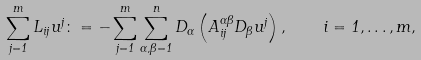Convert formula to latex. <formula><loc_0><loc_0><loc_500><loc_500>\sum _ { j = 1 } ^ { m } L _ { i j } u ^ { j } \colon = - \sum _ { j = 1 } ^ { m } \sum _ { \alpha , \beta = 1 } ^ { n } D _ { \alpha } \left ( A ^ { \alpha \beta } _ { i j } D _ { \beta } u ^ { j } \right ) , \quad i = 1 , \dots , m ,</formula> 